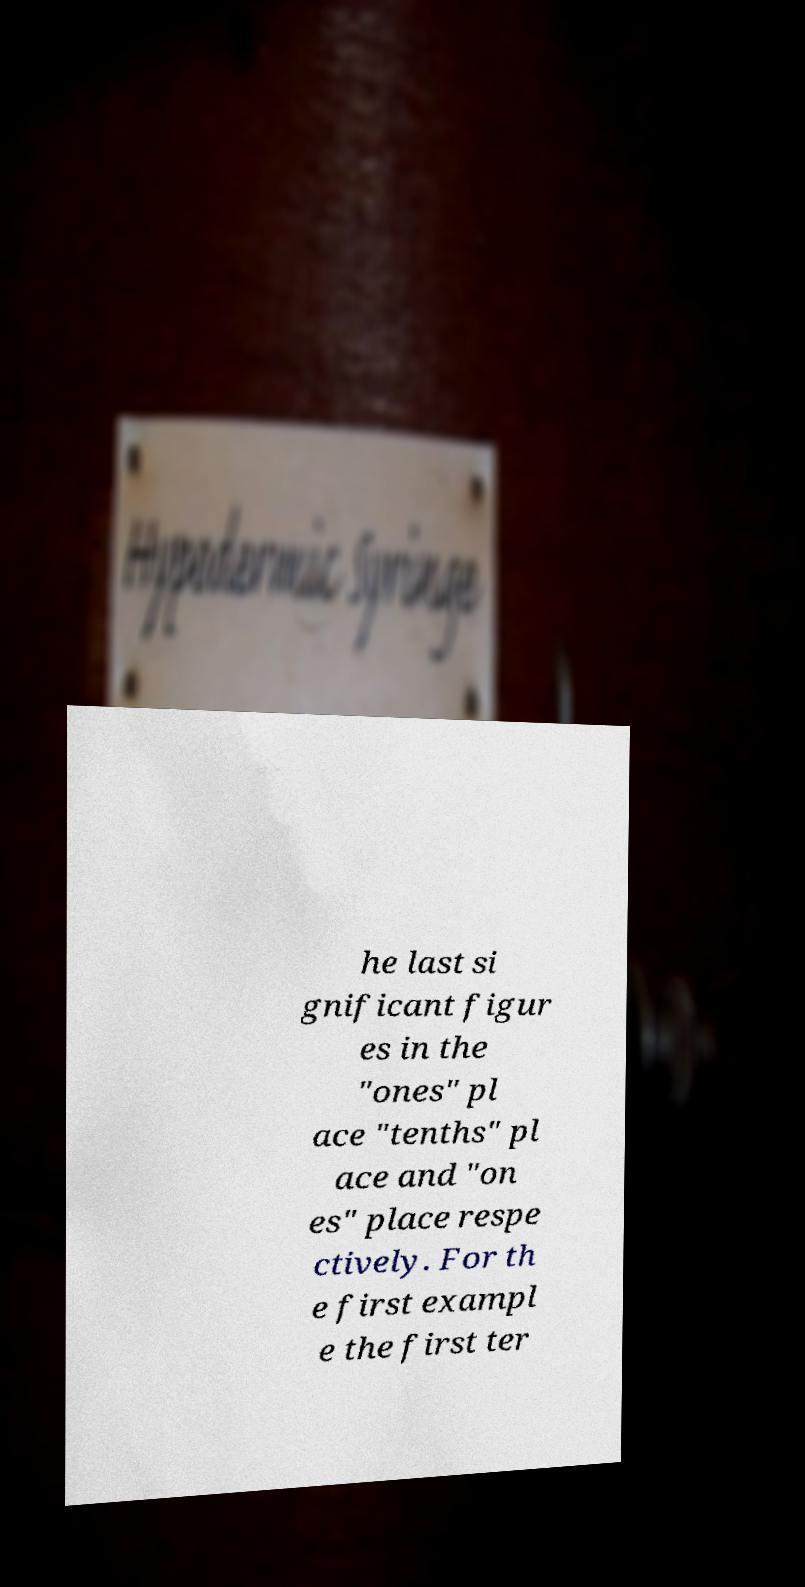For documentation purposes, I need the text within this image transcribed. Could you provide that? he last si gnificant figur es in the "ones" pl ace "tenths" pl ace and "on es" place respe ctively. For th e first exampl e the first ter 